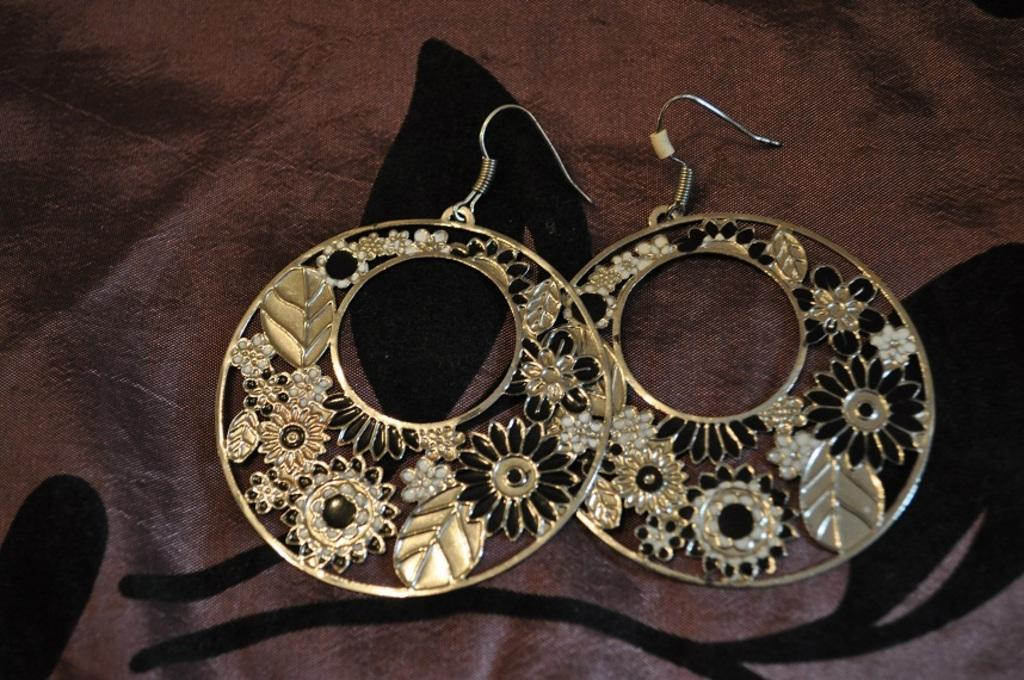What type of accessory is present in the image? There are earrings in the image. Where are the earrings placed in the image? The earrings are on a cloth. What is the limit of the battle in the image? There is no mention of a throat, limit, or battle in the image. 